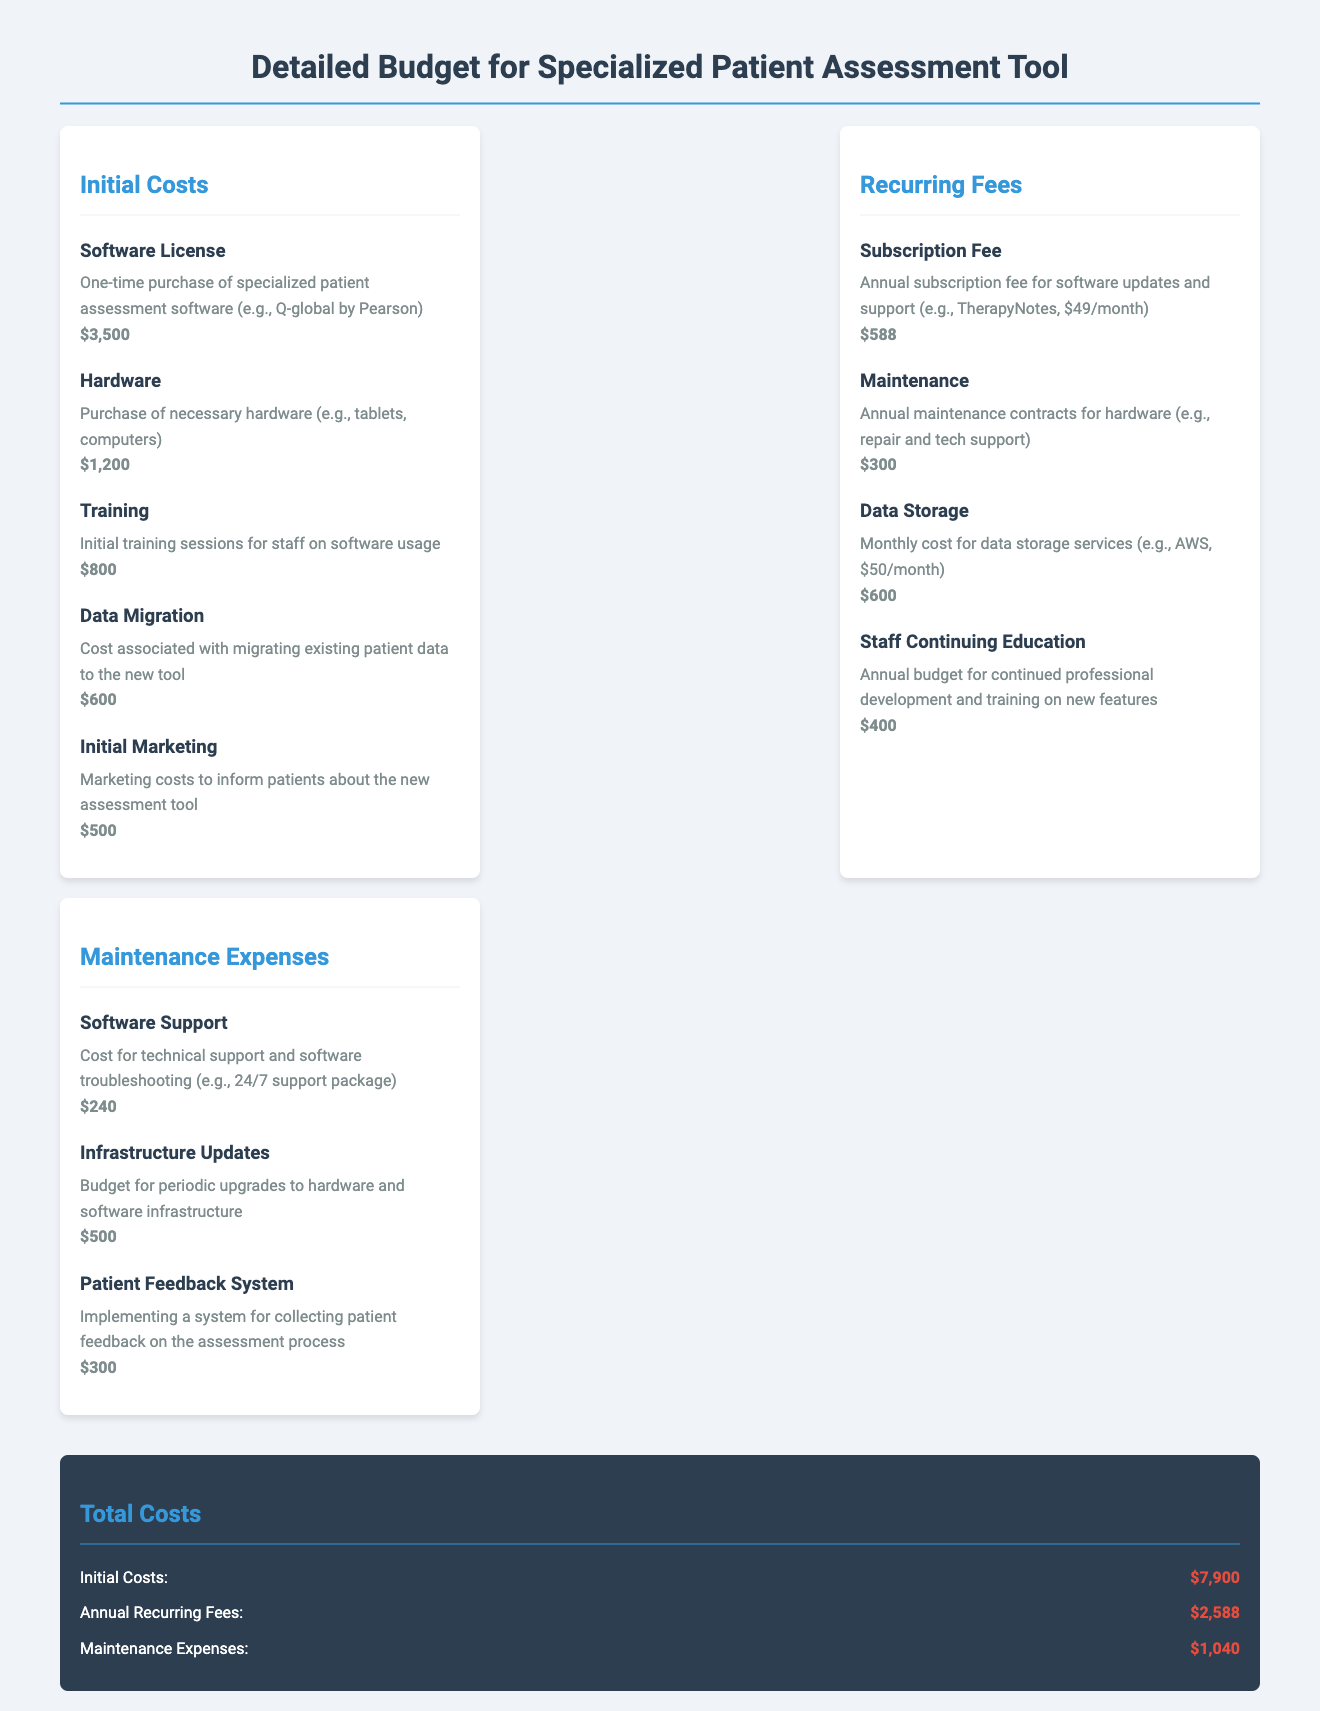what is the initial cost of the software license? The initial cost of the software license is stated explicitly in the initial costs section of the document.
Answer: $3,500 what is the total amount for initial costs? The total amount for initial costs is the sum of all initial costs listed in the document.
Answer: $7,900 what are the annual recurring fees for data storage? The recurring fee for data storage is provided in the recurring fees section of the document.
Answer: $600 how much is allocated for staff continuing education annually? The document specifies the annual budget allocated for staff continuing education.
Answer: $400 what is the cost for software support? The cost for software support is mentioned under maintenance expenses in the document.
Answer: $240 what is the total annual recurring fees? The total annual recurring fees is provided in the total costs section, summarizing all recurring fees.
Answer: $2,588 how much is planned for infrastructure updates? The planned budget for infrastructure updates is detailed in the maintenance expenses section of the document.
Answer: $500 what is the cost for initial marketing? The cost for initial marketing is listed under initial costs in the document.
Answer: $500 what type of tool is this budget for? The document specifies that the budget is for a specialized patient assessment tool.
Answer: Patient assessment tool 